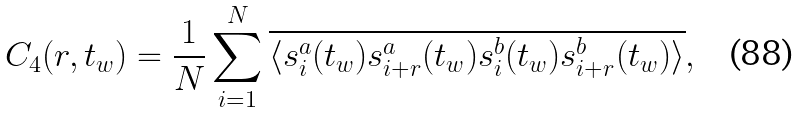<formula> <loc_0><loc_0><loc_500><loc_500>C _ { 4 } ( r , t _ { w } ) = \frac { 1 } { N } \sum _ { i = 1 } ^ { N } \overline { \langle s _ { i } ^ { a } ( t _ { w } ) s _ { i + r } ^ { a } ( t _ { w } ) s _ { i } ^ { b } ( t _ { w } ) s _ { i + r } ^ { b } ( t _ { w } ) \rangle } ,</formula> 